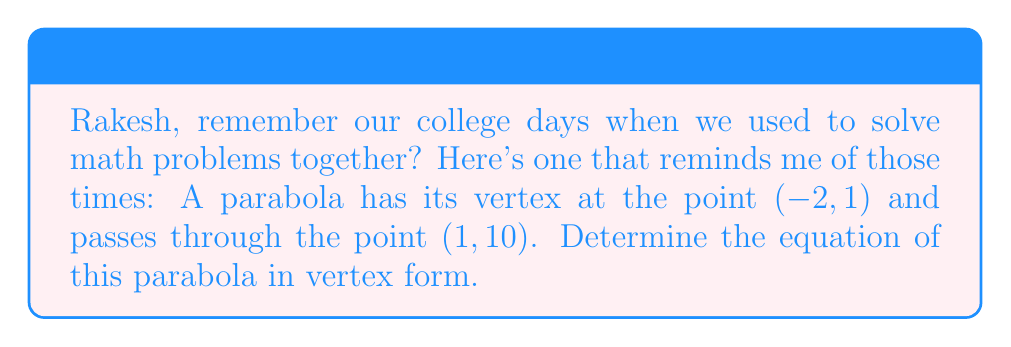Can you answer this question? Let's approach this step-by-step, Rakesh:

1) The vertex form of a parabola is given by:
   
   $$ y = a(x - h)^2 + k $$
   
   where $(h, k)$ is the vertex of the parabola.

2) We're given that the vertex is at $(-2, 1)$, so $h = -2$ and $k = 1$. Let's substitute these:
   
   $$ y = a(x - (-2))^2 + 1 $$
   $$ y = a(x + 2)^2 + 1 $$

3) Now we need to find the value of $a$. We can use the point $(1, 10)$ that the parabola passes through:
   
   $$ 10 = a(1 + 2)^2 + 1 $$
   $$ 10 = a(3)^2 + 1 $$
   $$ 10 = 9a + 1 $$

4) Solve for $a$:
   
   $$ 9 = 9a $$
   $$ a = 1 $$

5) Now that we have $a$, we can write the final equation:
   
   $$ y = 1(x + 2)^2 + 1 $$

Therefore, the equation of the parabola in vertex form is $y = (x + 2)^2 + 1$.
Answer: $y = (x + 2)^2 + 1$ 